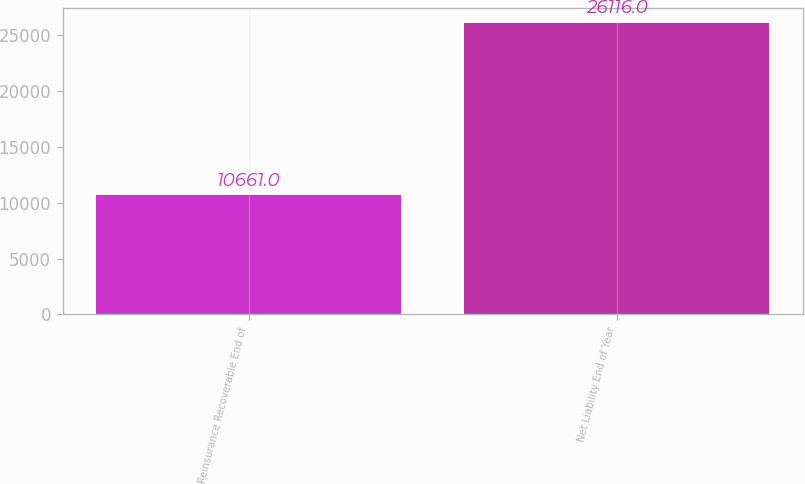Convert chart. <chart><loc_0><loc_0><loc_500><loc_500><bar_chart><fcel>Reinsurance Recoverable End of<fcel>Net Liability End of Year<nl><fcel>10661<fcel>26116<nl></chart> 